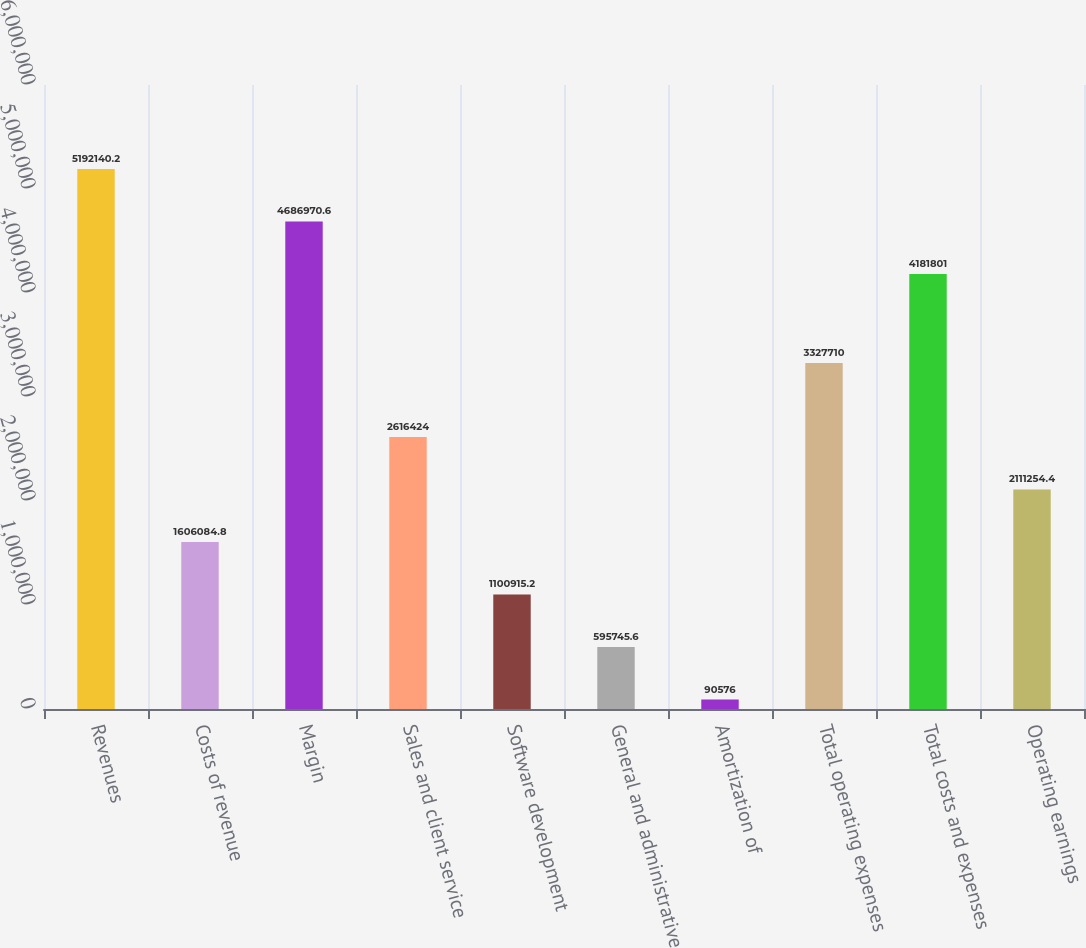Convert chart. <chart><loc_0><loc_0><loc_500><loc_500><bar_chart><fcel>Revenues<fcel>Costs of revenue<fcel>Margin<fcel>Sales and client service<fcel>Software development<fcel>General and administrative<fcel>Amortization of<fcel>Total operating expenses<fcel>Total costs and expenses<fcel>Operating earnings<nl><fcel>5.19214e+06<fcel>1.60608e+06<fcel>4.68697e+06<fcel>2.61642e+06<fcel>1.10092e+06<fcel>595746<fcel>90576<fcel>3.32771e+06<fcel>4.1818e+06<fcel>2.11125e+06<nl></chart> 